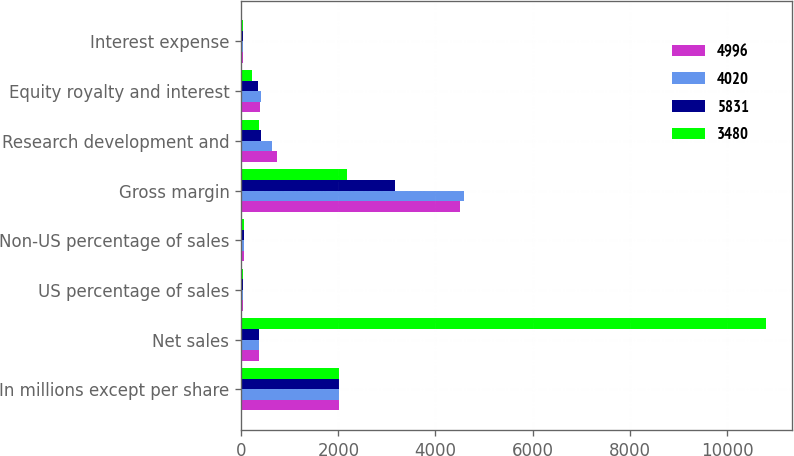Convert chart to OTSL. <chart><loc_0><loc_0><loc_500><loc_500><stacked_bar_chart><ecel><fcel>In millions except per share<fcel>Net sales<fcel>US percentage of sales<fcel>Non-US percentage of sales<fcel>Gross margin<fcel>Research development and<fcel>Equity royalty and interest<fcel>Interest expense<nl><fcel>4996<fcel>2012<fcel>362<fcel>47<fcel>53<fcel>4508<fcel>728<fcel>384<fcel>32<nl><fcel>4020<fcel>2011<fcel>362<fcel>41<fcel>59<fcel>4589<fcel>629<fcel>416<fcel>44<nl><fcel>5831<fcel>2010<fcel>362<fcel>36<fcel>64<fcel>3168<fcel>414<fcel>351<fcel>40<nl><fcel>3480<fcel>2009<fcel>10800<fcel>48<fcel>52<fcel>2169<fcel>362<fcel>214<fcel>35<nl></chart> 